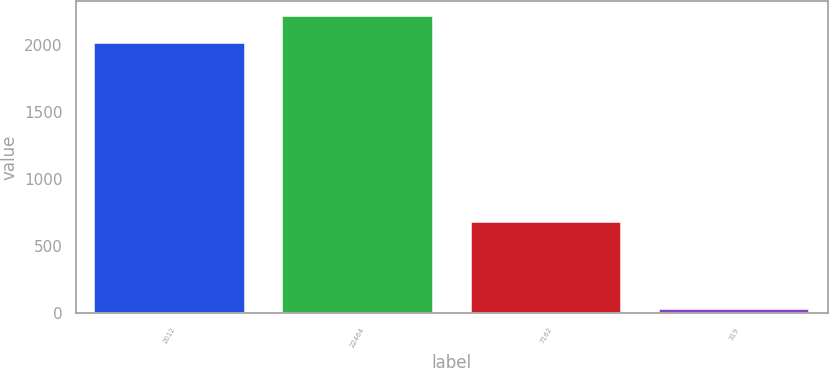<chart> <loc_0><loc_0><loc_500><loc_500><bar_chart><fcel>2012<fcel>22464<fcel>7162<fcel>319<nl><fcel>2011<fcel>2215.4<fcel>680.3<fcel>32.8<nl></chart> 